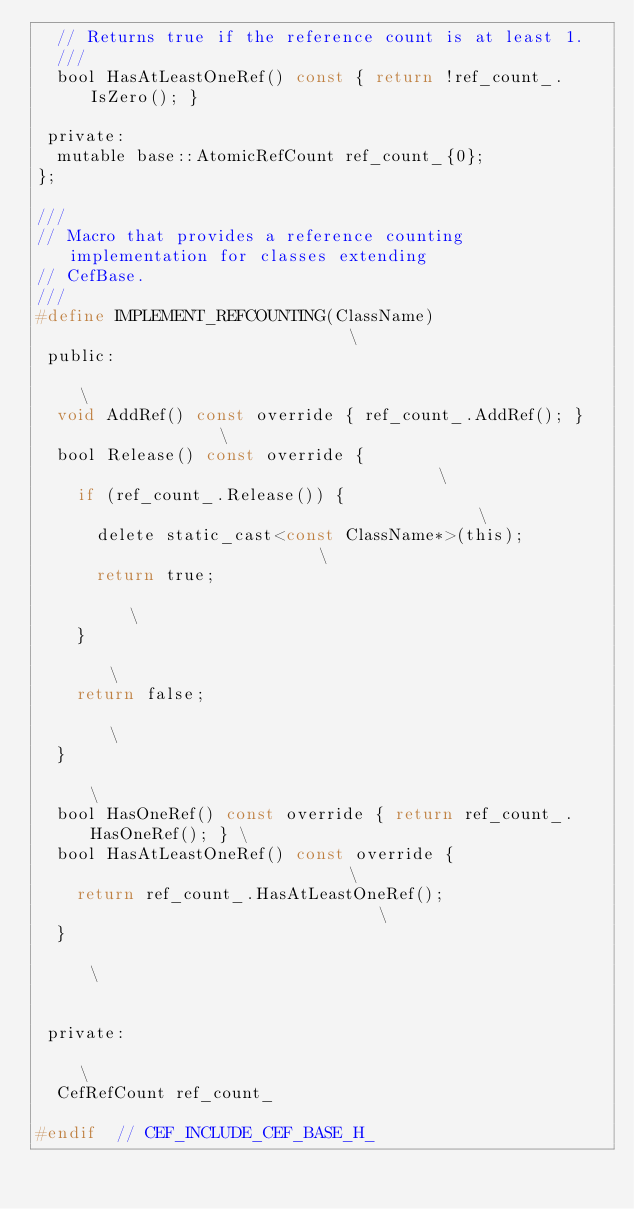<code> <loc_0><loc_0><loc_500><loc_500><_C_>  // Returns true if the reference count is at least 1.
  ///
  bool HasAtLeastOneRef() const { return !ref_count_.IsZero(); }

 private:
  mutable base::AtomicRefCount ref_count_{0};
};

///
// Macro that provides a reference counting implementation for classes extending
// CefBase.
///
#define IMPLEMENT_REFCOUNTING(ClassName)                             \
 public:                                                             \
  void AddRef() const override { ref_count_.AddRef(); }              \
  bool Release() const override {                                    \
    if (ref_count_.Release()) {                                      \
      delete static_cast<const ClassName*>(this);                    \
      return true;                                                   \
    }                                                                \
    return false;                                                    \
  }                                                                  \
  bool HasOneRef() const override { return ref_count_.HasOneRef(); } \
  bool HasAtLeastOneRef() const override {                           \
    return ref_count_.HasAtLeastOneRef();                            \
  }                                                                  \
                                                                     \
 private:                                                            \
  CefRefCount ref_count_

#endif  // CEF_INCLUDE_CEF_BASE_H_
</code> 